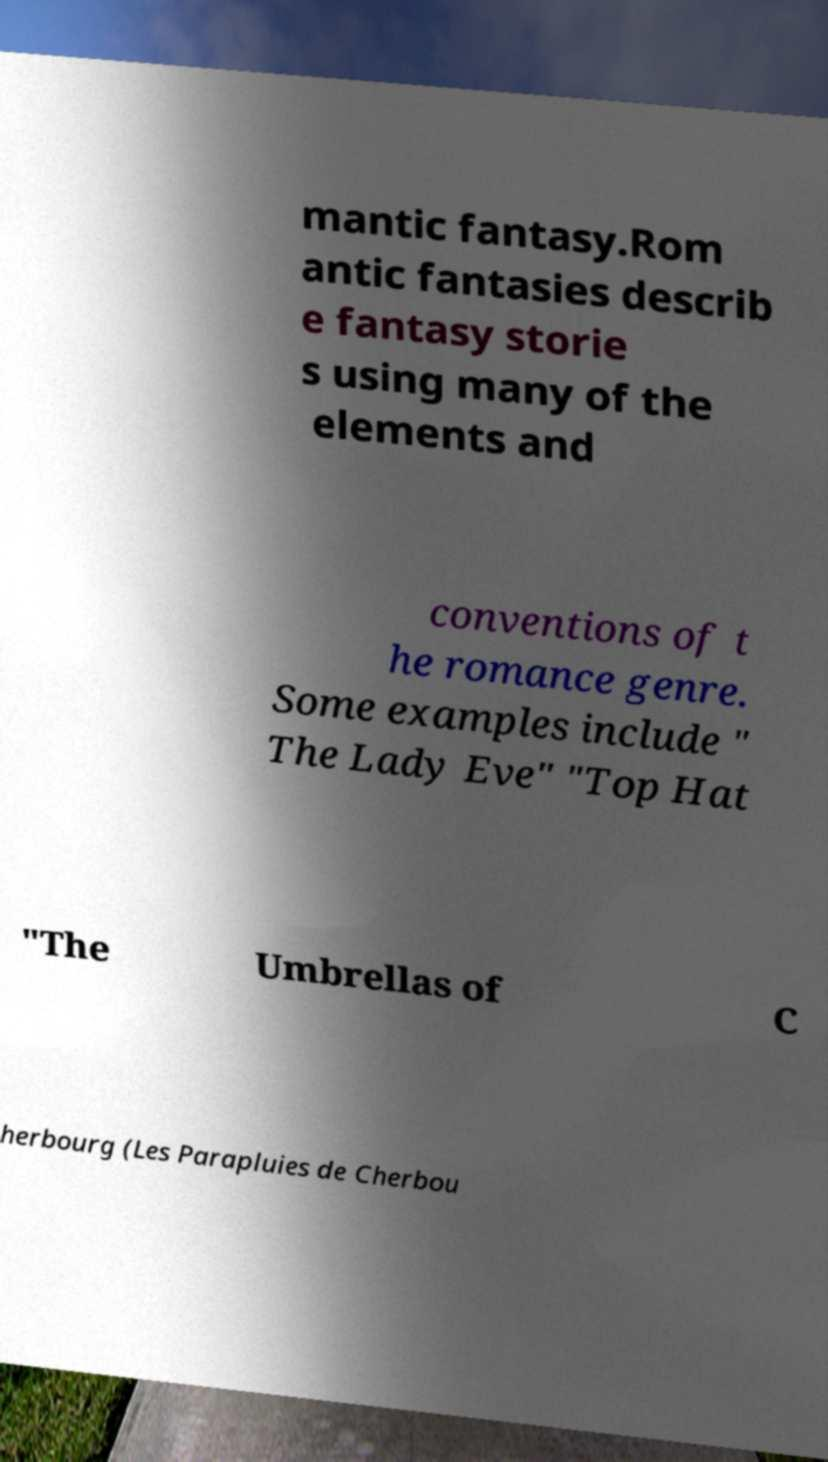Can you accurately transcribe the text from the provided image for me? mantic fantasy.Rom antic fantasies describ e fantasy storie s using many of the elements and conventions of t he romance genre. Some examples include " The Lady Eve" "Top Hat "The Umbrellas of C herbourg (Les Parapluies de Cherbou 